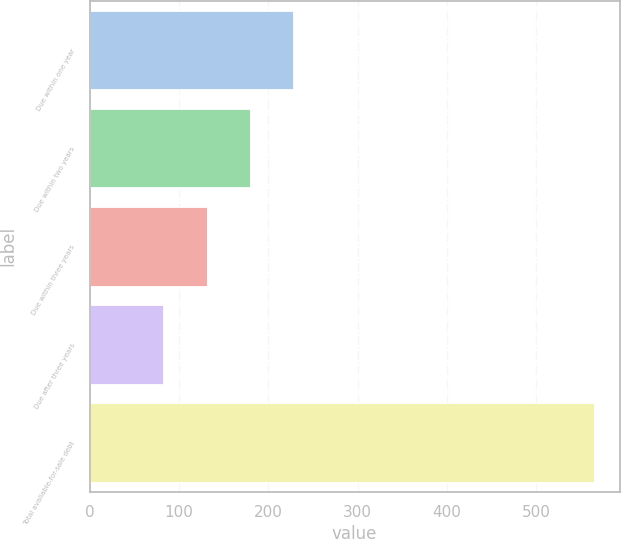Convert chart to OTSL. <chart><loc_0><loc_0><loc_500><loc_500><bar_chart><fcel>Due within one year<fcel>Due within two years<fcel>Due within three years<fcel>Due after three years<fcel>Total available-for-sale debt<nl><fcel>227.6<fcel>179.3<fcel>131<fcel>82<fcel>565<nl></chart> 